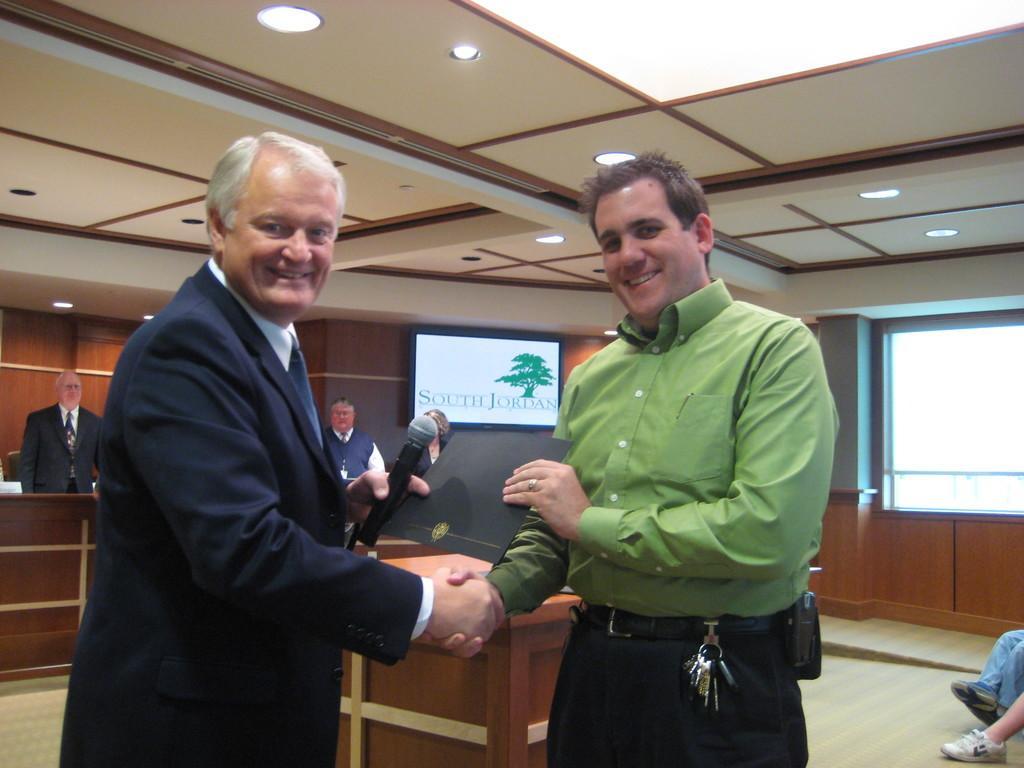Describe this image in one or two sentences. In this image we can see group of people standing. One person is standing and holding a microphone in his hand. other person is wearing green shirt and holding a black paper in his hand. In the background we can see some persons sitting and a screen on the wall. 